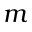Convert formula to latex. <formula><loc_0><loc_0><loc_500><loc_500>m</formula> 